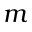Convert formula to latex. <formula><loc_0><loc_0><loc_500><loc_500>m</formula> 